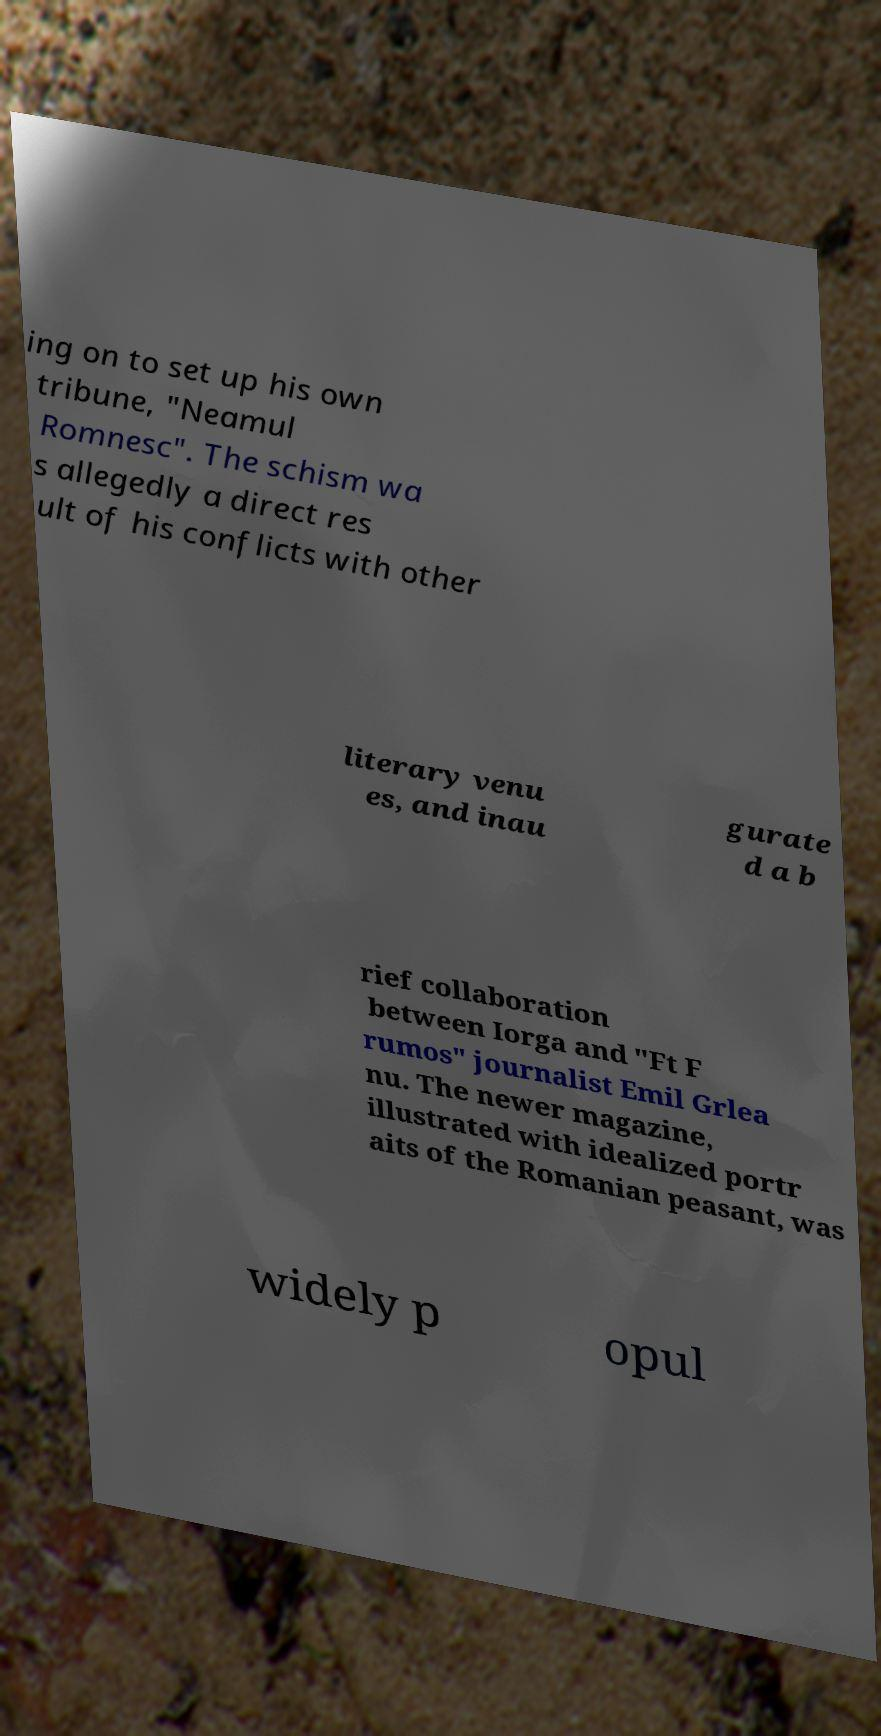Please read and relay the text visible in this image. What does it say? ing on to set up his own tribune, "Neamul Romnesc". The schism wa s allegedly a direct res ult of his conflicts with other literary venu es, and inau gurate d a b rief collaboration between Iorga and "Ft F rumos" journalist Emil Grlea nu. The newer magazine, illustrated with idealized portr aits of the Romanian peasant, was widely p opul 